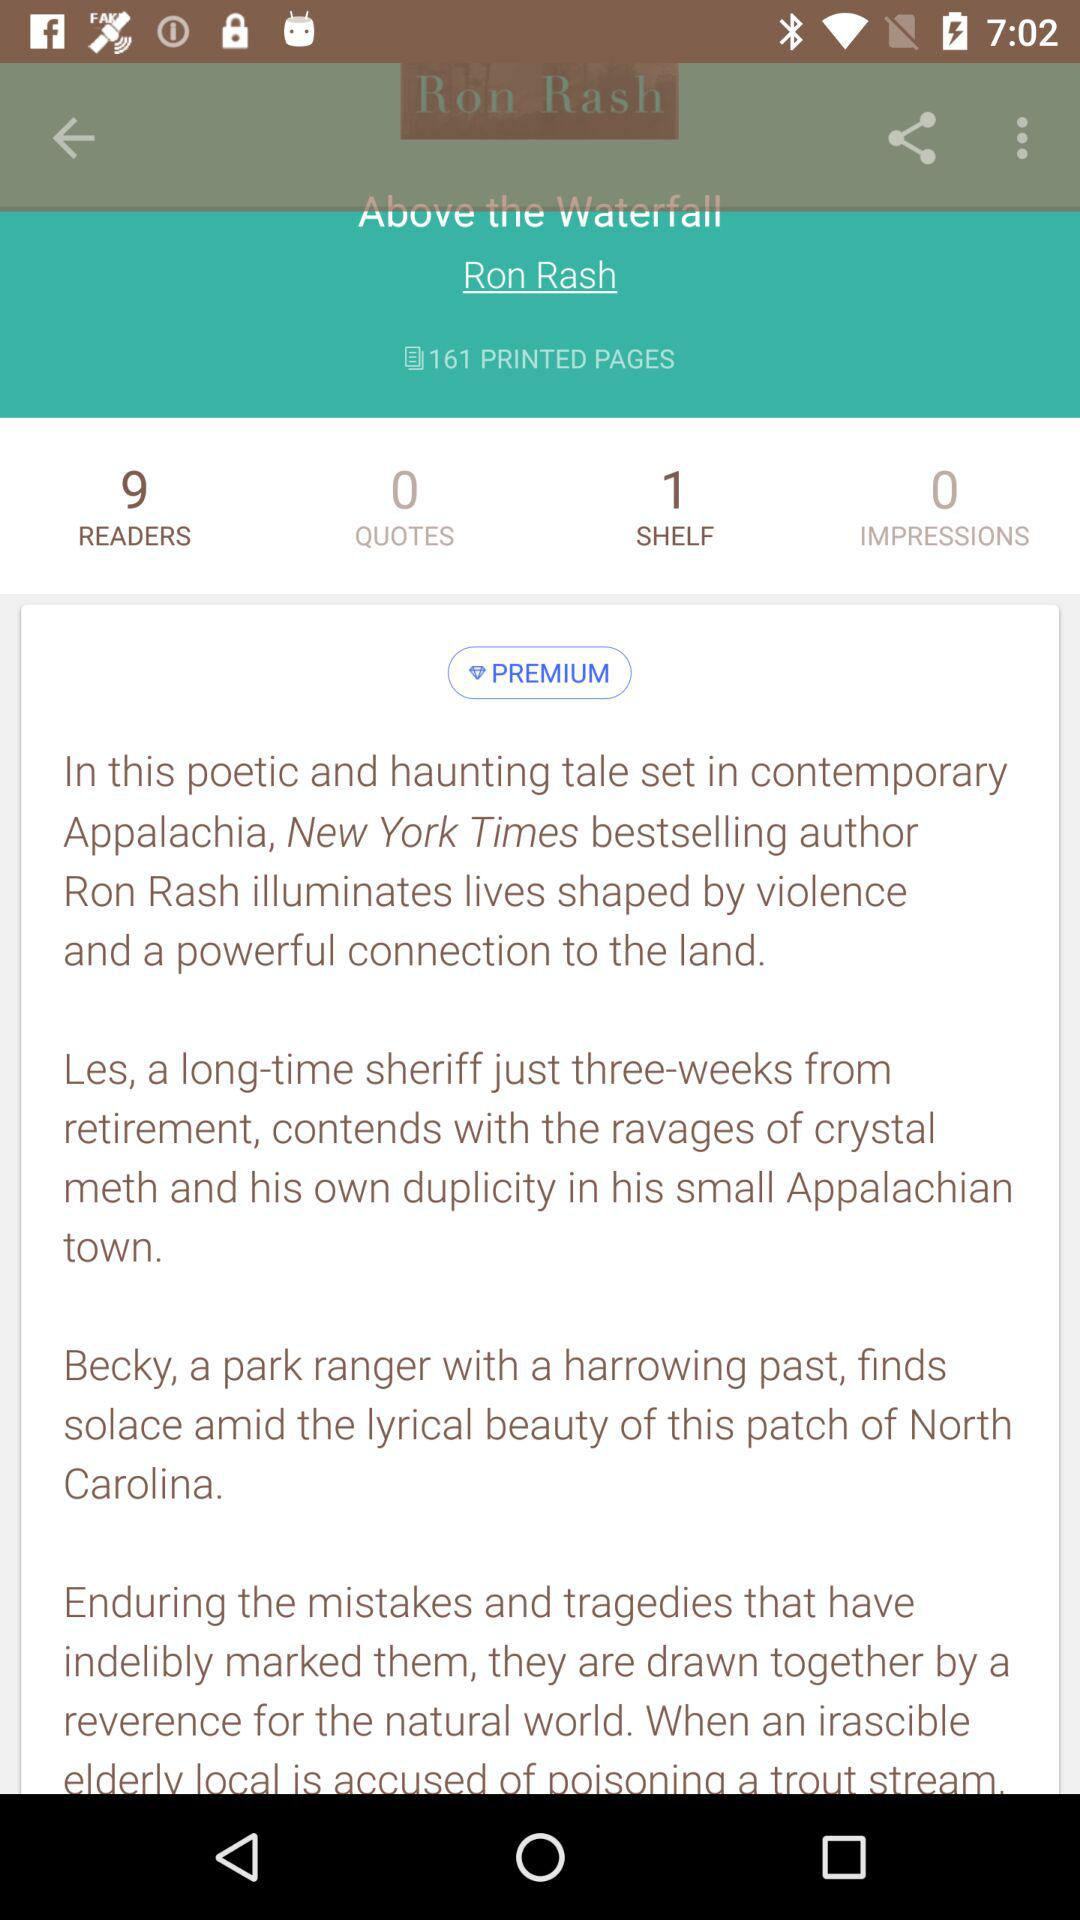Who is the author? The author is Ron Rash. 